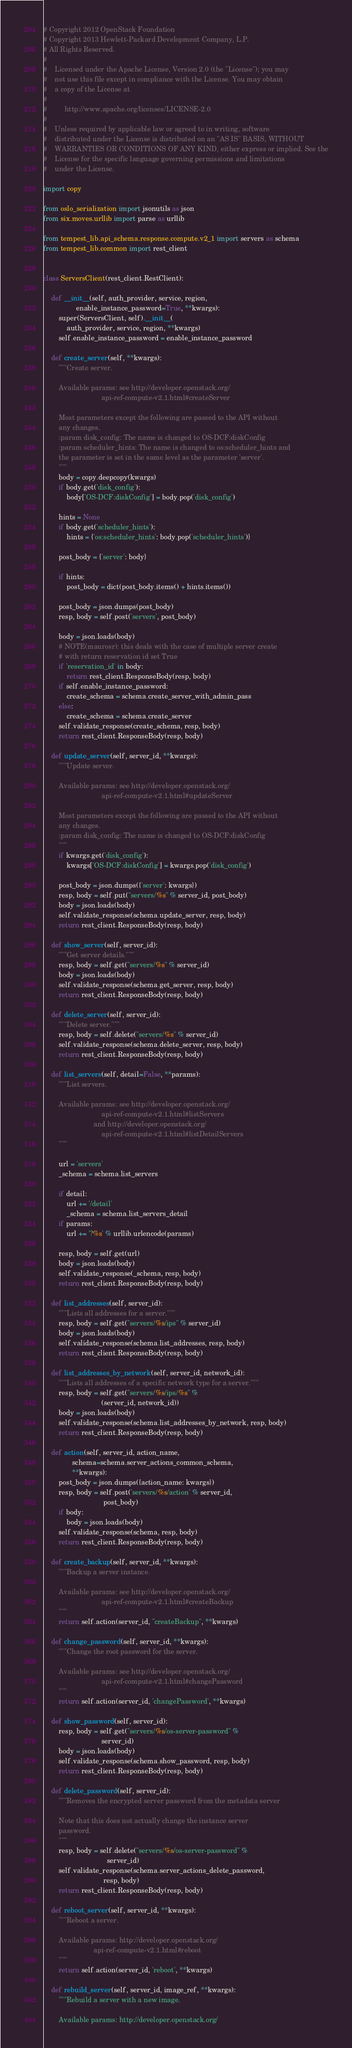<code> <loc_0><loc_0><loc_500><loc_500><_Python_># Copyright 2012 OpenStack Foundation
# Copyright 2013 Hewlett-Packard Development Company, L.P.
# All Rights Reserved.
#
#    Licensed under the Apache License, Version 2.0 (the "License"); you may
#    not use this file except in compliance with the License. You may obtain
#    a copy of the License at
#
#         http://www.apache.org/licenses/LICENSE-2.0
#
#    Unless required by applicable law or agreed to in writing, software
#    distributed under the License is distributed on an "AS IS" BASIS, WITHOUT
#    WARRANTIES OR CONDITIONS OF ANY KIND, either express or implied. See the
#    License for the specific language governing permissions and limitations
#    under the License.

import copy

from oslo_serialization import jsonutils as json
from six.moves.urllib import parse as urllib

from tempest_lib.api_schema.response.compute.v2_1 import servers as schema
from tempest_lib.common import rest_client


class ServersClient(rest_client.RestClient):

    def __init__(self, auth_provider, service, region,
                 enable_instance_password=True, **kwargs):
        super(ServersClient, self).__init__(
            auth_provider, service, region, **kwargs)
        self.enable_instance_password = enable_instance_password

    def create_server(self, **kwargs):
        """Create server.

        Available params: see http://developer.openstack.org/
                              api-ref-compute-v2.1.html#createServer

        Most parameters except the following are passed to the API without
        any changes.
        :param disk_config: The name is changed to OS-DCF:diskConfig
        :param scheduler_hints: The name is changed to os:scheduler_hints and
        the parameter is set in the same level as the parameter 'server'.
        """
        body = copy.deepcopy(kwargs)
        if body.get('disk_config'):
            body['OS-DCF:diskConfig'] = body.pop('disk_config')

        hints = None
        if body.get('scheduler_hints'):
            hints = {'os:scheduler_hints': body.pop('scheduler_hints')}

        post_body = {'server': body}

        if hints:
            post_body = dict(post_body.items() + hints.items())

        post_body = json.dumps(post_body)
        resp, body = self.post('servers', post_body)

        body = json.loads(body)
        # NOTE(maurosr): this deals with the case of multiple server create
        # with return reservation id set True
        if 'reservation_id' in body:
            return rest_client.ResponseBody(resp, body)
        if self.enable_instance_password:
            create_schema = schema.create_server_with_admin_pass
        else:
            create_schema = schema.create_server
        self.validate_response(create_schema, resp, body)
        return rest_client.ResponseBody(resp, body)

    def update_server(self, server_id, **kwargs):
        """Update server.

        Available params: see http://developer.openstack.org/
                              api-ref-compute-v2.1.html#updateServer

        Most parameters except the following are passed to the API without
        any changes.
        :param disk_config: The name is changed to OS-DCF:diskConfig
        """
        if kwargs.get('disk_config'):
            kwargs['OS-DCF:diskConfig'] = kwargs.pop('disk_config')

        post_body = json.dumps({'server': kwargs})
        resp, body = self.put("servers/%s" % server_id, post_body)
        body = json.loads(body)
        self.validate_response(schema.update_server, resp, body)
        return rest_client.ResponseBody(resp, body)

    def show_server(self, server_id):
        """Get server details."""
        resp, body = self.get("servers/%s" % server_id)
        body = json.loads(body)
        self.validate_response(schema.get_server, resp, body)
        return rest_client.ResponseBody(resp, body)

    def delete_server(self, server_id):
        """Delete server."""
        resp, body = self.delete("servers/%s" % server_id)
        self.validate_response(schema.delete_server, resp, body)
        return rest_client.ResponseBody(resp, body)

    def list_servers(self, detail=False, **params):
        """List servers.

        Available params: see http://developer.openstack.org/
                              api-ref-compute-v2.1.html#listServers
                          and http://developer.openstack.org/
                              api-ref-compute-v2.1.html#listDetailServers
        """

        url = 'servers'
        _schema = schema.list_servers

        if detail:
            url += '/detail'
            _schema = schema.list_servers_detail
        if params:
            url += '?%s' % urllib.urlencode(params)

        resp, body = self.get(url)
        body = json.loads(body)
        self.validate_response(_schema, resp, body)
        return rest_client.ResponseBody(resp, body)

    def list_addresses(self, server_id):
        """Lists all addresses for a server."""
        resp, body = self.get("servers/%s/ips" % server_id)
        body = json.loads(body)
        self.validate_response(schema.list_addresses, resp, body)
        return rest_client.ResponseBody(resp, body)

    def list_addresses_by_network(self, server_id, network_id):
        """Lists all addresses of a specific network type for a server."""
        resp, body = self.get("servers/%s/ips/%s" %
                              (server_id, network_id))
        body = json.loads(body)
        self.validate_response(schema.list_addresses_by_network, resp, body)
        return rest_client.ResponseBody(resp, body)

    def action(self, server_id, action_name,
               schema=schema.server_actions_common_schema,
               **kwargs):
        post_body = json.dumps({action_name: kwargs})
        resp, body = self.post('servers/%s/action' % server_id,
                               post_body)
        if body:
            body = json.loads(body)
        self.validate_response(schema, resp, body)
        return rest_client.ResponseBody(resp, body)

    def create_backup(self, server_id, **kwargs):
        """Backup a server instance.

        Available params: see http://developer.openstack.org/
                              api-ref-compute-v2.1.html#createBackup
        """
        return self.action(server_id, "createBackup", **kwargs)

    def change_password(self, server_id, **kwargs):
        """Change the root password for the server.

        Available params: see http://developer.openstack.org/
                              api-ref-compute-v2.1.html#changePassword
        """
        return self.action(server_id, 'changePassword', **kwargs)

    def show_password(self, server_id):
        resp, body = self.get("servers/%s/os-server-password" %
                              server_id)
        body = json.loads(body)
        self.validate_response(schema.show_password, resp, body)
        return rest_client.ResponseBody(resp, body)

    def delete_password(self, server_id):
        """Removes the encrypted server password from the metadata server

        Note that this does not actually change the instance server
        password.
        """
        resp, body = self.delete("servers/%s/os-server-password" %
                                 server_id)
        self.validate_response(schema.server_actions_delete_password,
                               resp, body)
        return rest_client.ResponseBody(resp, body)

    def reboot_server(self, server_id, **kwargs):
        """Reboot a server.

        Available params: http://developer.openstack.org/
                          api-ref-compute-v2.1.html#reboot
        """
        return self.action(server_id, 'reboot', **kwargs)

    def rebuild_server(self, server_id, image_ref, **kwargs):
        """Rebuild a server with a new image.

        Available params: http://developer.openstack.org/</code> 